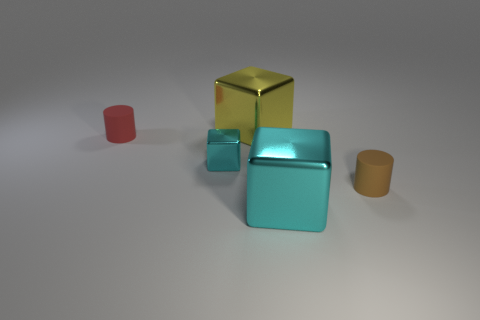Do the red matte cylinder and the brown rubber cylinder have the same size?
Your answer should be compact. Yes. What size is the cyan block that is behind the brown matte cylinder on the right side of the large shiny cube behind the tiny red rubber cylinder?
Offer a terse response. Small. There is a tiny object that is on the right side of the tiny shiny cube; what color is it?
Your response must be concise. Brown. Are there more small shiny cubes that are on the right side of the yellow thing than big yellow shiny things?
Your response must be concise. No. There is a small cyan metal thing that is in front of the yellow metallic thing; is its shape the same as the big cyan thing?
Keep it short and to the point. Yes. What number of blue objects are small rubber things or large cubes?
Your response must be concise. 0. Is the number of large cyan metallic balls greater than the number of yellow things?
Provide a short and direct response. No. What is the color of the other shiny object that is the same size as the red object?
Keep it short and to the point. Cyan. How many balls are either small things or big shiny objects?
Offer a terse response. 0. Is the shape of the brown object the same as the metal thing that is behind the small red rubber cylinder?
Your answer should be very brief. No. 